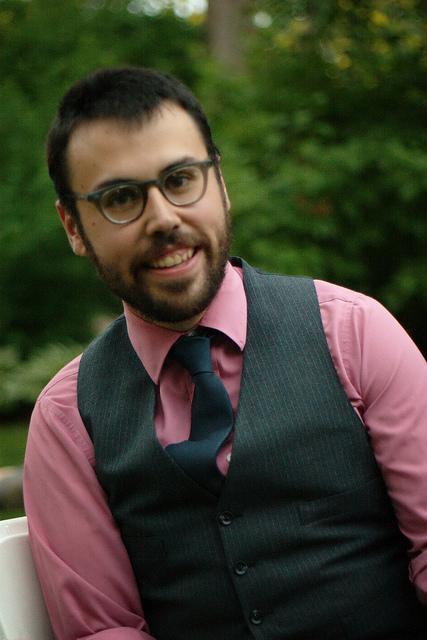What is this person doing?
Answer briefly. Smiling. What is the style of this man's hair?
Short answer required. Short. What color is the man's eyes?
Give a very brief answer. Brown. Is the person wearing a hat?
Write a very short answer. No. What color is this boy's shirt?
Give a very brief answer. Pink. How many men are there?
Short answer required. 1. What does the man have on his neck?
Short answer required. Tie. Is this an adult?
Quick response, please. Yes. What is this person wearing?
Keep it brief. Suit. What is the color of tie this man have on?
Keep it brief. Black. Does this guy have big eyes?
Keep it brief. No. What color is the man's shirt?
Short answer required. Pink. Does the pattern on the tie resemble an electronic circuit board?
Give a very brief answer. No. Are there trees?
Write a very short answer. Yes. Is the man wearing velvet?
Answer briefly. No. 